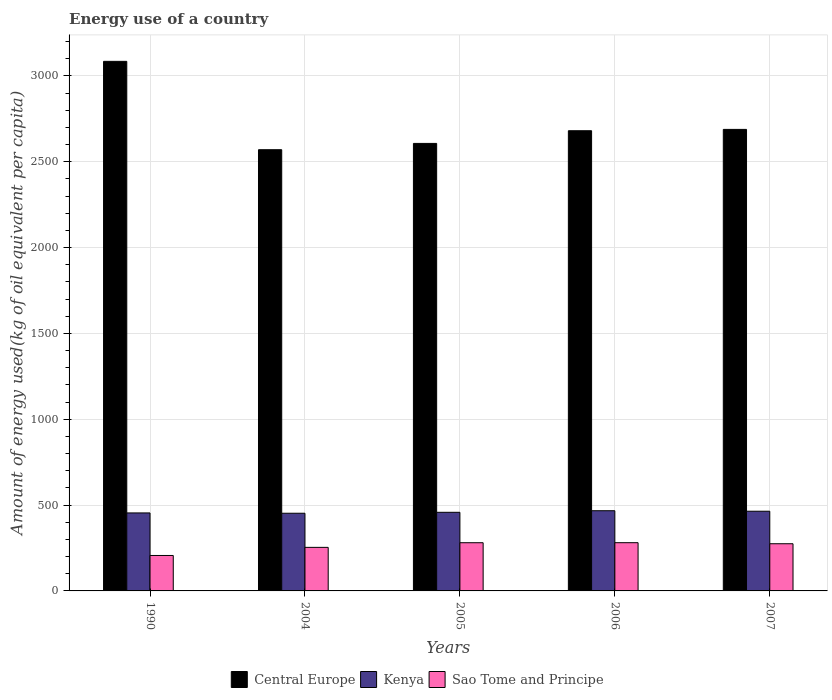How many groups of bars are there?
Provide a short and direct response. 5. Are the number of bars per tick equal to the number of legend labels?
Provide a short and direct response. Yes. Are the number of bars on each tick of the X-axis equal?
Give a very brief answer. Yes. How many bars are there on the 3rd tick from the left?
Your response must be concise. 3. How many bars are there on the 1st tick from the right?
Make the answer very short. 3. What is the amount of energy used in in Sao Tome and Principe in 2006?
Make the answer very short. 281. Across all years, what is the maximum amount of energy used in in Sao Tome and Principe?
Your answer should be compact. 281. Across all years, what is the minimum amount of energy used in in Sao Tome and Principe?
Make the answer very short. 206.52. What is the total amount of energy used in in Central Europe in the graph?
Give a very brief answer. 1.36e+04. What is the difference between the amount of energy used in in Sao Tome and Principe in 1990 and that in 2004?
Provide a short and direct response. -47.27. What is the difference between the amount of energy used in in Sao Tome and Principe in 1990 and the amount of energy used in in Central Europe in 2004?
Your response must be concise. -2363.99. What is the average amount of energy used in in Central Europe per year?
Offer a terse response. 2726.57. In the year 2007, what is the difference between the amount of energy used in in Kenya and amount of energy used in in Central Europe?
Your answer should be very brief. -2224.54. What is the ratio of the amount of energy used in in Sao Tome and Principe in 2004 to that in 2005?
Your answer should be very brief. 0.9. Is the amount of energy used in in Kenya in 1990 less than that in 2007?
Give a very brief answer. Yes. Is the difference between the amount of energy used in in Kenya in 2004 and 2006 greater than the difference between the amount of energy used in in Central Europe in 2004 and 2006?
Your response must be concise. Yes. What is the difference between the highest and the second highest amount of energy used in in Central Europe?
Give a very brief answer. 396.47. What is the difference between the highest and the lowest amount of energy used in in Kenya?
Offer a very short reply. 14.65. In how many years, is the amount of energy used in in Sao Tome and Principe greater than the average amount of energy used in in Sao Tome and Principe taken over all years?
Make the answer very short. 3. Is the sum of the amount of energy used in in Central Europe in 2005 and 2007 greater than the maximum amount of energy used in in Sao Tome and Principe across all years?
Your answer should be compact. Yes. What does the 3rd bar from the left in 2006 represents?
Provide a short and direct response. Sao Tome and Principe. What does the 2nd bar from the right in 1990 represents?
Provide a short and direct response. Kenya. What is the difference between two consecutive major ticks on the Y-axis?
Keep it short and to the point. 500. Are the values on the major ticks of Y-axis written in scientific E-notation?
Ensure brevity in your answer.  No. Does the graph contain any zero values?
Your answer should be compact. No. Does the graph contain grids?
Provide a succinct answer. Yes. Where does the legend appear in the graph?
Provide a short and direct response. Bottom center. How many legend labels are there?
Your answer should be compact. 3. What is the title of the graph?
Offer a terse response. Energy use of a country. What is the label or title of the X-axis?
Your answer should be compact. Years. What is the label or title of the Y-axis?
Your response must be concise. Amount of energy used(kg of oil equivalent per capita). What is the Amount of energy used(kg of oil equivalent per capita) of Central Europe in 1990?
Offer a very short reply. 3085.28. What is the Amount of energy used(kg of oil equivalent per capita) of Kenya in 1990?
Make the answer very short. 454.41. What is the Amount of energy used(kg of oil equivalent per capita) of Sao Tome and Principe in 1990?
Your answer should be very brief. 206.52. What is the Amount of energy used(kg of oil equivalent per capita) in Central Europe in 2004?
Provide a succinct answer. 2570.51. What is the Amount of energy used(kg of oil equivalent per capita) of Kenya in 2004?
Offer a terse response. 452.53. What is the Amount of energy used(kg of oil equivalent per capita) of Sao Tome and Principe in 2004?
Keep it short and to the point. 253.79. What is the Amount of energy used(kg of oil equivalent per capita) of Central Europe in 2005?
Ensure brevity in your answer.  2607.18. What is the Amount of energy used(kg of oil equivalent per capita) in Kenya in 2005?
Your answer should be compact. 458.06. What is the Amount of energy used(kg of oil equivalent per capita) of Sao Tome and Principe in 2005?
Provide a succinct answer. 280.78. What is the Amount of energy used(kg of oil equivalent per capita) in Central Europe in 2006?
Provide a short and direct response. 2681.06. What is the Amount of energy used(kg of oil equivalent per capita) in Kenya in 2006?
Your answer should be compact. 467.17. What is the Amount of energy used(kg of oil equivalent per capita) of Sao Tome and Principe in 2006?
Ensure brevity in your answer.  281. What is the Amount of energy used(kg of oil equivalent per capita) in Central Europe in 2007?
Make the answer very short. 2688.81. What is the Amount of energy used(kg of oil equivalent per capita) in Kenya in 2007?
Keep it short and to the point. 464.27. What is the Amount of energy used(kg of oil equivalent per capita) in Sao Tome and Principe in 2007?
Provide a short and direct response. 274.89. Across all years, what is the maximum Amount of energy used(kg of oil equivalent per capita) of Central Europe?
Ensure brevity in your answer.  3085.28. Across all years, what is the maximum Amount of energy used(kg of oil equivalent per capita) in Kenya?
Offer a terse response. 467.17. Across all years, what is the maximum Amount of energy used(kg of oil equivalent per capita) in Sao Tome and Principe?
Keep it short and to the point. 281. Across all years, what is the minimum Amount of energy used(kg of oil equivalent per capita) of Central Europe?
Provide a succinct answer. 2570.51. Across all years, what is the minimum Amount of energy used(kg of oil equivalent per capita) in Kenya?
Make the answer very short. 452.53. Across all years, what is the minimum Amount of energy used(kg of oil equivalent per capita) in Sao Tome and Principe?
Ensure brevity in your answer.  206.52. What is the total Amount of energy used(kg of oil equivalent per capita) in Central Europe in the graph?
Offer a terse response. 1.36e+04. What is the total Amount of energy used(kg of oil equivalent per capita) of Kenya in the graph?
Give a very brief answer. 2296.45. What is the total Amount of energy used(kg of oil equivalent per capita) of Sao Tome and Principe in the graph?
Give a very brief answer. 1296.98. What is the difference between the Amount of energy used(kg of oil equivalent per capita) of Central Europe in 1990 and that in 2004?
Your response must be concise. 514.77. What is the difference between the Amount of energy used(kg of oil equivalent per capita) in Kenya in 1990 and that in 2004?
Make the answer very short. 1.89. What is the difference between the Amount of energy used(kg of oil equivalent per capita) in Sao Tome and Principe in 1990 and that in 2004?
Provide a short and direct response. -47.27. What is the difference between the Amount of energy used(kg of oil equivalent per capita) of Central Europe in 1990 and that in 2005?
Your answer should be compact. 478.1. What is the difference between the Amount of energy used(kg of oil equivalent per capita) of Kenya in 1990 and that in 2005?
Your answer should be very brief. -3.65. What is the difference between the Amount of energy used(kg of oil equivalent per capita) of Sao Tome and Principe in 1990 and that in 2005?
Provide a short and direct response. -74.26. What is the difference between the Amount of energy used(kg of oil equivalent per capita) in Central Europe in 1990 and that in 2006?
Your answer should be very brief. 404.22. What is the difference between the Amount of energy used(kg of oil equivalent per capita) of Kenya in 1990 and that in 2006?
Offer a very short reply. -12.76. What is the difference between the Amount of energy used(kg of oil equivalent per capita) of Sao Tome and Principe in 1990 and that in 2006?
Provide a short and direct response. -74.48. What is the difference between the Amount of energy used(kg of oil equivalent per capita) in Central Europe in 1990 and that in 2007?
Make the answer very short. 396.47. What is the difference between the Amount of energy used(kg of oil equivalent per capita) in Kenya in 1990 and that in 2007?
Offer a terse response. -9.86. What is the difference between the Amount of energy used(kg of oil equivalent per capita) in Sao Tome and Principe in 1990 and that in 2007?
Your response must be concise. -68.37. What is the difference between the Amount of energy used(kg of oil equivalent per capita) of Central Europe in 2004 and that in 2005?
Your answer should be compact. -36.67. What is the difference between the Amount of energy used(kg of oil equivalent per capita) of Kenya in 2004 and that in 2005?
Provide a short and direct response. -5.54. What is the difference between the Amount of energy used(kg of oil equivalent per capita) in Sao Tome and Principe in 2004 and that in 2005?
Make the answer very short. -26.99. What is the difference between the Amount of energy used(kg of oil equivalent per capita) of Central Europe in 2004 and that in 2006?
Offer a terse response. -110.55. What is the difference between the Amount of energy used(kg of oil equivalent per capita) in Kenya in 2004 and that in 2006?
Provide a short and direct response. -14.65. What is the difference between the Amount of energy used(kg of oil equivalent per capita) in Sao Tome and Principe in 2004 and that in 2006?
Your response must be concise. -27.21. What is the difference between the Amount of energy used(kg of oil equivalent per capita) in Central Europe in 2004 and that in 2007?
Provide a succinct answer. -118.3. What is the difference between the Amount of energy used(kg of oil equivalent per capita) of Kenya in 2004 and that in 2007?
Ensure brevity in your answer.  -11.74. What is the difference between the Amount of energy used(kg of oil equivalent per capita) in Sao Tome and Principe in 2004 and that in 2007?
Offer a very short reply. -21.1. What is the difference between the Amount of energy used(kg of oil equivalent per capita) of Central Europe in 2005 and that in 2006?
Keep it short and to the point. -73.89. What is the difference between the Amount of energy used(kg of oil equivalent per capita) of Kenya in 2005 and that in 2006?
Give a very brief answer. -9.11. What is the difference between the Amount of energy used(kg of oil equivalent per capita) of Sao Tome and Principe in 2005 and that in 2006?
Make the answer very short. -0.22. What is the difference between the Amount of energy used(kg of oil equivalent per capita) of Central Europe in 2005 and that in 2007?
Ensure brevity in your answer.  -81.64. What is the difference between the Amount of energy used(kg of oil equivalent per capita) of Kenya in 2005 and that in 2007?
Offer a terse response. -6.2. What is the difference between the Amount of energy used(kg of oil equivalent per capita) of Sao Tome and Principe in 2005 and that in 2007?
Offer a very short reply. 5.89. What is the difference between the Amount of energy used(kg of oil equivalent per capita) in Central Europe in 2006 and that in 2007?
Your answer should be very brief. -7.75. What is the difference between the Amount of energy used(kg of oil equivalent per capita) of Kenya in 2006 and that in 2007?
Your answer should be very brief. 2.9. What is the difference between the Amount of energy used(kg of oil equivalent per capita) of Sao Tome and Principe in 2006 and that in 2007?
Give a very brief answer. 6.11. What is the difference between the Amount of energy used(kg of oil equivalent per capita) of Central Europe in 1990 and the Amount of energy used(kg of oil equivalent per capita) of Kenya in 2004?
Keep it short and to the point. 2632.75. What is the difference between the Amount of energy used(kg of oil equivalent per capita) in Central Europe in 1990 and the Amount of energy used(kg of oil equivalent per capita) in Sao Tome and Principe in 2004?
Your response must be concise. 2831.49. What is the difference between the Amount of energy used(kg of oil equivalent per capita) of Kenya in 1990 and the Amount of energy used(kg of oil equivalent per capita) of Sao Tome and Principe in 2004?
Your answer should be very brief. 200.63. What is the difference between the Amount of energy used(kg of oil equivalent per capita) of Central Europe in 1990 and the Amount of energy used(kg of oil equivalent per capita) of Kenya in 2005?
Provide a short and direct response. 2627.21. What is the difference between the Amount of energy used(kg of oil equivalent per capita) in Central Europe in 1990 and the Amount of energy used(kg of oil equivalent per capita) in Sao Tome and Principe in 2005?
Offer a very short reply. 2804.5. What is the difference between the Amount of energy used(kg of oil equivalent per capita) of Kenya in 1990 and the Amount of energy used(kg of oil equivalent per capita) of Sao Tome and Principe in 2005?
Your response must be concise. 173.63. What is the difference between the Amount of energy used(kg of oil equivalent per capita) in Central Europe in 1990 and the Amount of energy used(kg of oil equivalent per capita) in Kenya in 2006?
Keep it short and to the point. 2618.11. What is the difference between the Amount of energy used(kg of oil equivalent per capita) of Central Europe in 1990 and the Amount of energy used(kg of oil equivalent per capita) of Sao Tome and Principe in 2006?
Your answer should be compact. 2804.28. What is the difference between the Amount of energy used(kg of oil equivalent per capita) of Kenya in 1990 and the Amount of energy used(kg of oil equivalent per capita) of Sao Tome and Principe in 2006?
Your answer should be compact. 173.41. What is the difference between the Amount of energy used(kg of oil equivalent per capita) of Central Europe in 1990 and the Amount of energy used(kg of oil equivalent per capita) of Kenya in 2007?
Provide a succinct answer. 2621.01. What is the difference between the Amount of energy used(kg of oil equivalent per capita) of Central Europe in 1990 and the Amount of energy used(kg of oil equivalent per capita) of Sao Tome and Principe in 2007?
Offer a terse response. 2810.39. What is the difference between the Amount of energy used(kg of oil equivalent per capita) in Kenya in 1990 and the Amount of energy used(kg of oil equivalent per capita) in Sao Tome and Principe in 2007?
Provide a succinct answer. 179.52. What is the difference between the Amount of energy used(kg of oil equivalent per capita) of Central Europe in 2004 and the Amount of energy used(kg of oil equivalent per capita) of Kenya in 2005?
Your response must be concise. 2112.45. What is the difference between the Amount of energy used(kg of oil equivalent per capita) in Central Europe in 2004 and the Amount of energy used(kg of oil equivalent per capita) in Sao Tome and Principe in 2005?
Ensure brevity in your answer.  2289.74. What is the difference between the Amount of energy used(kg of oil equivalent per capita) of Kenya in 2004 and the Amount of energy used(kg of oil equivalent per capita) of Sao Tome and Principe in 2005?
Your answer should be compact. 171.75. What is the difference between the Amount of energy used(kg of oil equivalent per capita) of Central Europe in 2004 and the Amount of energy used(kg of oil equivalent per capita) of Kenya in 2006?
Your response must be concise. 2103.34. What is the difference between the Amount of energy used(kg of oil equivalent per capita) in Central Europe in 2004 and the Amount of energy used(kg of oil equivalent per capita) in Sao Tome and Principe in 2006?
Ensure brevity in your answer.  2289.51. What is the difference between the Amount of energy used(kg of oil equivalent per capita) in Kenya in 2004 and the Amount of energy used(kg of oil equivalent per capita) in Sao Tome and Principe in 2006?
Provide a succinct answer. 171.53. What is the difference between the Amount of energy used(kg of oil equivalent per capita) in Central Europe in 2004 and the Amount of energy used(kg of oil equivalent per capita) in Kenya in 2007?
Give a very brief answer. 2106.24. What is the difference between the Amount of energy used(kg of oil equivalent per capita) in Central Europe in 2004 and the Amount of energy used(kg of oil equivalent per capita) in Sao Tome and Principe in 2007?
Make the answer very short. 2295.62. What is the difference between the Amount of energy used(kg of oil equivalent per capita) in Kenya in 2004 and the Amount of energy used(kg of oil equivalent per capita) in Sao Tome and Principe in 2007?
Ensure brevity in your answer.  177.64. What is the difference between the Amount of energy used(kg of oil equivalent per capita) of Central Europe in 2005 and the Amount of energy used(kg of oil equivalent per capita) of Kenya in 2006?
Ensure brevity in your answer.  2140.01. What is the difference between the Amount of energy used(kg of oil equivalent per capita) in Central Europe in 2005 and the Amount of energy used(kg of oil equivalent per capita) in Sao Tome and Principe in 2006?
Keep it short and to the point. 2326.18. What is the difference between the Amount of energy used(kg of oil equivalent per capita) in Kenya in 2005 and the Amount of energy used(kg of oil equivalent per capita) in Sao Tome and Principe in 2006?
Offer a terse response. 177.07. What is the difference between the Amount of energy used(kg of oil equivalent per capita) in Central Europe in 2005 and the Amount of energy used(kg of oil equivalent per capita) in Kenya in 2007?
Provide a succinct answer. 2142.91. What is the difference between the Amount of energy used(kg of oil equivalent per capita) of Central Europe in 2005 and the Amount of energy used(kg of oil equivalent per capita) of Sao Tome and Principe in 2007?
Your answer should be compact. 2332.29. What is the difference between the Amount of energy used(kg of oil equivalent per capita) of Kenya in 2005 and the Amount of energy used(kg of oil equivalent per capita) of Sao Tome and Principe in 2007?
Keep it short and to the point. 183.17. What is the difference between the Amount of energy used(kg of oil equivalent per capita) in Central Europe in 2006 and the Amount of energy used(kg of oil equivalent per capita) in Kenya in 2007?
Offer a very short reply. 2216.79. What is the difference between the Amount of energy used(kg of oil equivalent per capita) in Central Europe in 2006 and the Amount of energy used(kg of oil equivalent per capita) in Sao Tome and Principe in 2007?
Keep it short and to the point. 2406.17. What is the difference between the Amount of energy used(kg of oil equivalent per capita) in Kenya in 2006 and the Amount of energy used(kg of oil equivalent per capita) in Sao Tome and Principe in 2007?
Provide a short and direct response. 192.28. What is the average Amount of energy used(kg of oil equivalent per capita) of Central Europe per year?
Make the answer very short. 2726.57. What is the average Amount of energy used(kg of oil equivalent per capita) of Kenya per year?
Your response must be concise. 459.29. What is the average Amount of energy used(kg of oil equivalent per capita) of Sao Tome and Principe per year?
Make the answer very short. 259.39. In the year 1990, what is the difference between the Amount of energy used(kg of oil equivalent per capita) in Central Europe and Amount of energy used(kg of oil equivalent per capita) in Kenya?
Provide a short and direct response. 2630.87. In the year 1990, what is the difference between the Amount of energy used(kg of oil equivalent per capita) of Central Europe and Amount of energy used(kg of oil equivalent per capita) of Sao Tome and Principe?
Your answer should be compact. 2878.76. In the year 1990, what is the difference between the Amount of energy used(kg of oil equivalent per capita) in Kenya and Amount of energy used(kg of oil equivalent per capita) in Sao Tome and Principe?
Ensure brevity in your answer.  247.89. In the year 2004, what is the difference between the Amount of energy used(kg of oil equivalent per capita) in Central Europe and Amount of energy used(kg of oil equivalent per capita) in Kenya?
Give a very brief answer. 2117.99. In the year 2004, what is the difference between the Amount of energy used(kg of oil equivalent per capita) of Central Europe and Amount of energy used(kg of oil equivalent per capita) of Sao Tome and Principe?
Provide a short and direct response. 2316.73. In the year 2004, what is the difference between the Amount of energy used(kg of oil equivalent per capita) in Kenya and Amount of energy used(kg of oil equivalent per capita) in Sao Tome and Principe?
Your answer should be compact. 198.74. In the year 2005, what is the difference between the Amount of energy used(kg of oil equivalent per capita) in Central Europe and Amount of energy used(kg of oil equivalent per capita) in Kenya?
Offer a terse response. 2149.11. In the year 2005, what is the difference between the Amount of energy used(kg of oil equivalent per capita) of Central Europe and Amount of energy used(kg of oil equivalent per capita) of Sao Tome and Principe?
Give a very brief answer. 2326.4. In the year 2005, what is the difference between the Amount of energy used(kg of oil equivalent per capita) in Kenya and Amount of energy used(kg of oil equivalent per capita) in Sao Tome and Principe?
Provide a short and direct response. 177.29. In the year 2006, what is the difference between the Amount of energy used(kg of oil equivalent per capita) in Central Europe and Amount of energy used(kg of oil equivalent per capita) in Kenya?
Ensure brevity in your answer.  2213.89. In the year 2006, what is the difference between the Amount of energy used(kg of oil equivalent per capita) in Central Europe and Amount of energy used(kg of oil equivalent per capita) in Sao Tome and Principe?
Keep it short and to the point. 2400.06. In the year 2006, what is the difference between the Amount of energy used(kg of oil equivalent per capita) of Kenya and Amount of energy used(kg of oil equivalent per capita) of Sao Tome and Principe?
Provide a short and direct response. 186.17. In the year 2007, what is the difference between the Amount of energy used(kg of oil equivalent per capita) in Central Europe and Amount of energy used(kg of oil equivalent per capita) in Kenya?
Offer a very short reply. 2224.54. In the year 2007, what is the difference between the Amount of energy used(kg of oil equivalent per capita) of Central Europe and Amount of energy used(kg of oil equivalent per capita) of Sao Tome and Principe?
Your response must be concise. 2413.92. In the year 2007, what is the difference between the Amount of energy used(kg of oil equivalent per capita) in Kenya and Amount of energy used(kg of oil equivalent per capita) in Sao Tome and Principe?
Your response must be concise. 189.38. What is the ratio of the Amount of energy used(kg of oil equivalent per capita) in Central Europe in 1990 to that in 2004?
Provide a short and direct response. 1.2. What is the ratio of the Amount of energy used(kg of oil equivalent per capita) in Kenya in 1990 to that in 2004?
Your response must be concise. 1. What is the ratio of the Amount of energy used(kg of oil equivalent per capita) of Sao Tome and Principe in 1990 to that in 2004?
Offer a terse response. 0.81. What is the ratio of the Amount of energy used(kg of oil equivalent per capita) of Central Europe in 1990 to that in 2005?
Provide a short and direct response. 1.18. What is the ratio of the Amount of energy used(kg of oil equivalent per capita) of Kenya in 1990 to that in 2005?
Your answer should be compact. 0.99. What is the ratio of the Amount of energy used(kg of oil equivalent per capita) of Sao Tome and Principe in 1990 to that in 2005?
Offer a very short reply. 0.74. What is the ratio of the Amount of energy used(kg of oil equivalent per capita) of Central Europe in 1990 to that in 2006?
Offer a terse response. 1.15. What is the ratio of the Amount of energy used(kg of oil equivalent per capita) in Kenya in 1990 to that in 2006?
Provide a succinct answer. 0.97. What is the ratio of the Amount of energy used(kg of oil equivalent per capita) of Sao Tome and Principe in 1990 to that in 2006?
Your response must be concise. 0.73. What is the ratio of the Amount of energy used(kg of oil equivalent per capita) of Central Europe in 1990 to that in 2007?
Keep it short and to the point. 1.15. What is the ratio of the Amount of energy used(kg of oil equivalent per capita) in Kenya in 1990 to that in 2007?
Your answer should be very brief. 0.98. What is the ratio of the Amount of energy used(kg of oil equivalent per capita) in Sao Tome and Principe in 1990 to that in 2007?
Provide a succinct answer. 0.75. What is the ratio of the Amount of energy used(kg of oil equivalent per capita) in Central Europe in 2004 to that in 2005?
Provide a short and direct response. 0.99. What is the ratio of the Amount of energy used(kg of oil equivalent per capita) of Kenya in 2004 to that in 2005?
Offer a terse response. 0.99. What is the ratio of the Amount of energy used(kg of oil equivalent per capita) of Sao Tome and Principe in 2004 to that in 2005?
Offer a very short reply. 0.9. What is the ratio of the Amount of energy used(kg of oil equivalent per capita) in Central Europe in 2004 to that in 2006?
Give a very brief answer. 0.96. What is the ratio of the Amount of energy used(kg of oil equivalent per capita) of Kenya in 2004 to that in 2006?
Give a very brief answer. 0.97. What is the ratio of the Amount of energy used(kg of oil equivalent per capita) in Sao Tome and Principe in 2004 to that in 2006?
Your answer should be very brief. 0.9. What is the ratio of the Amount of energy used(kg of oil equivalent per capita) in Central Europe in 2004 to that in 2007?
Make the answer very short. 0.96. What is the ratio of the Amount of energy used(kg of oil equivalent per capita) in Kenya in 2004 to that in 2007?
Make the answer very short. 0.97. What is the ratio of the Amount of energy used(kg of oil equivalent per capita) in Sao Tome and Principe in 2004 to that in 2007?
Your answer should be compact. 0.92. What is the ratio of the Amount of energy used(kg of oil equivalent per capita) of Central Europe in 2005 to that in 2006?
Provide a succinct answer. 0.97. What is the ratio of the Amount of energy used(kg of oil equivalent per capita) in Kenya in 2005 to that in 2006?
Offer a very short reply. 0.98. What is the ratio of the Amount of energy used(kg of oil equivalent per capita) in Sao Tome and Principe in 2005 to that in 2006?
Your answer should be compact. 1. What is the ratio of the Amount of energy used(kg of oil equivalent per capita) of Central Europe in 2005 to that in 2007?
Provide a short and direct response. 0.97. What is the ratio of the Amount of energy used(kg of oil equivalent per capita) of Kenya in 2005 to that in 2007?
Give a very brief answer. 0.99. What is the ratio of the Amount of energy used(kg of oil equivalent per capita) of Sao Tome and Principe in 2005 to that in 2007?
Offer a very short reply. 1.02. What is the ratio of the Amount of energy used(kg of oil equivalent per capita) of Central Europe in 2006 to that in 2007?
Keep it short and to the point. 1. What is the ratio of the Amount of energy used(kg of oil equivalent per capita) of Sao Tome and Principe in 2006 to that in 2007?
Your answer should be compact. 1.02. What is the difference between the highest and the second highest Amount of energy used(kg of oil equivalent per capita) of Central Europe?
Give a very brief answer. 396.47. What is the difference between the highest and the second highest Amount of energy used(kg of oil equivalent per capita) of Kenya?
Your answer should be compact. 2.9. What is the difference between the highest and the second highest Amount of energy used(kg of oil equivalent per capita) of Sao Tome and Principe?
Offer a very short reply. 0.22. What is the difference between the highest and the lowest Amount of energy used(kg of oil equivalent per capita) in Central Europe?
Make the answer very short. 514.77. What is the difference between the highest and the lowest Amount of energy used(kg of oil equivalent per capita) in Kenya?
Offer a very short reply. 14.65. What is the difference between the highest and the lowest Amount of energy used(kg of oil equivalent per capita) of Sao Tome and Principe?
Ensure brevity in your answer.  74.48. 